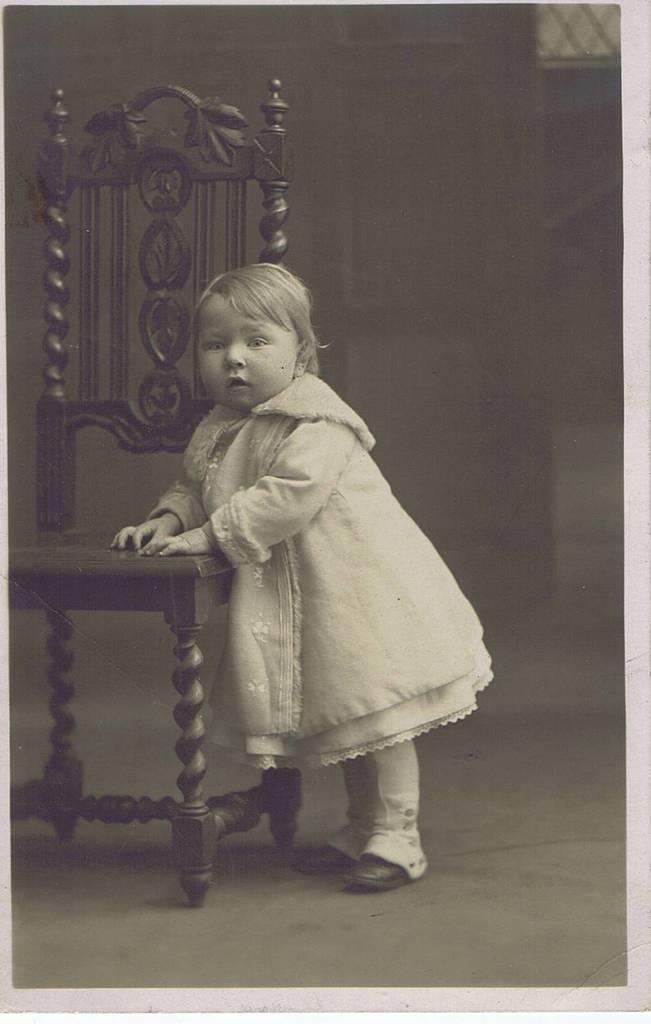Describe this image in one or two sentences. A little girl is standing by keeping her hands on a chair. 